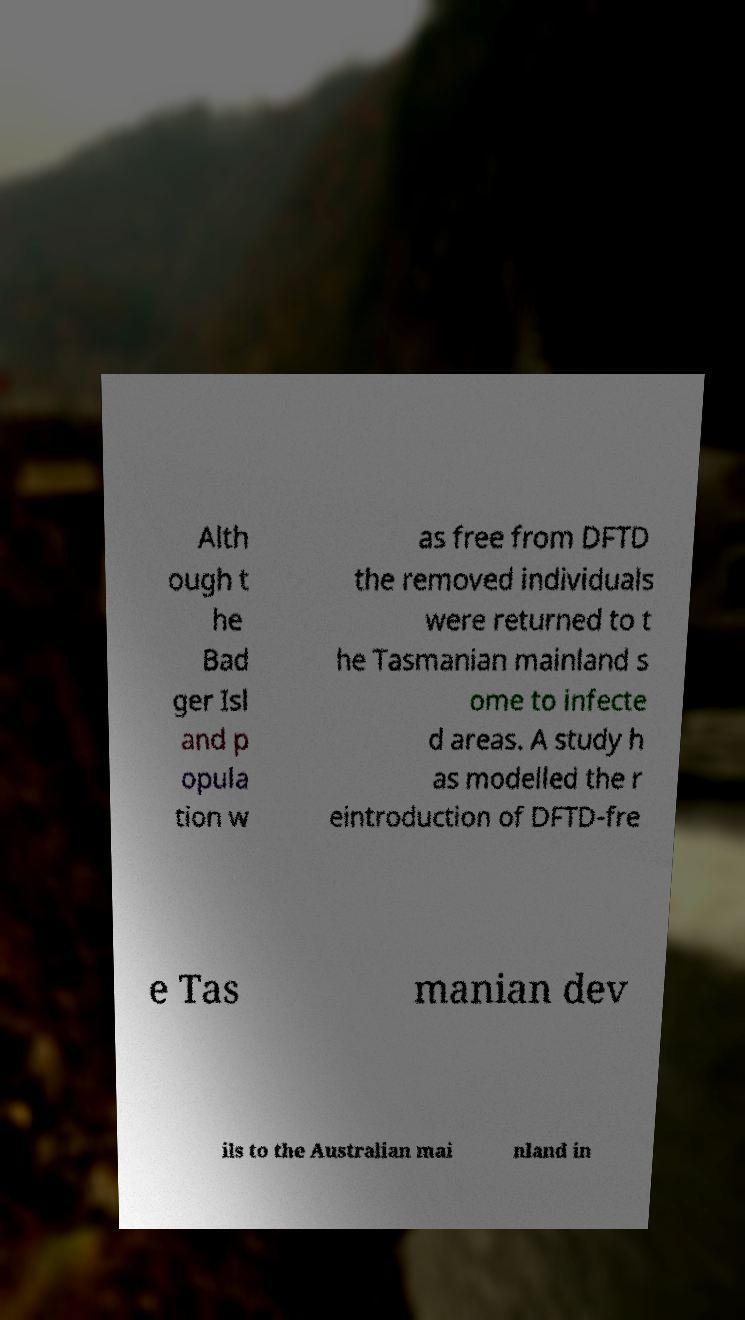Please read and relay the text visible in this image. What does it say? Alth ough t he Bad ger Isl and p opula tion w as free from DFTD the removed individuals were returned to t he Tasmanian mainland s ome to infecte d areas. A study h as modelled the r eintroduction of DFTD-fre e Tas manian dev ils to the Australian mai nland in 